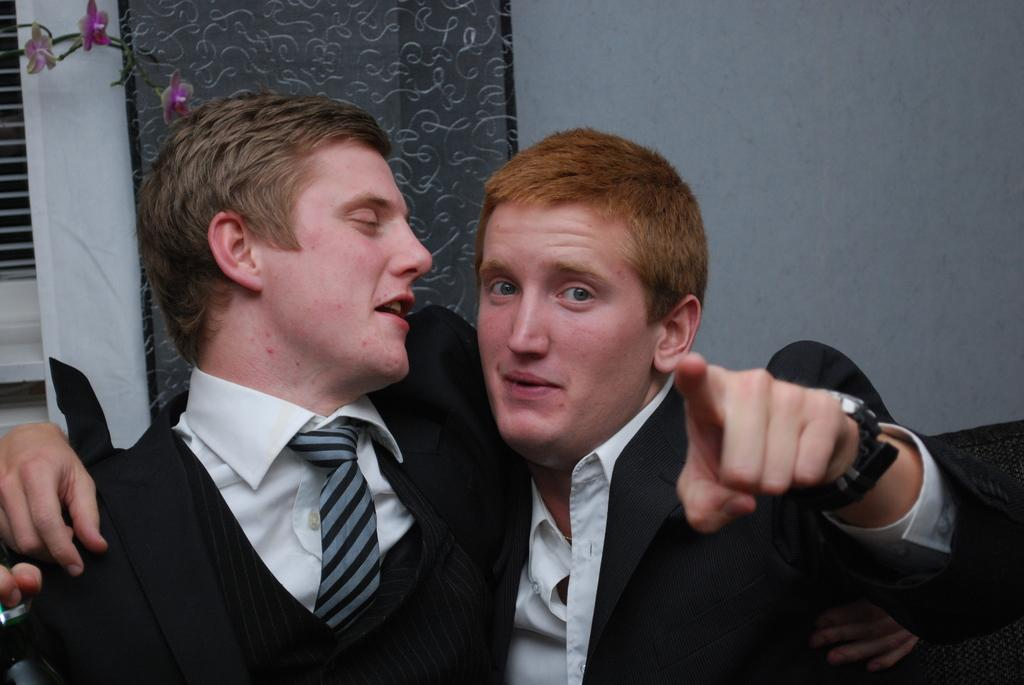How many people are in the image? There are two men in the image. Where are the men located? The men are in a room. What can be seen in the background of the image? There is a wall, a window, a curtain, and artificial flowers in the background of the image. What type of feather can be seen in the image? There is no feather present in the image. What discovery was made by the judge in the image? There is no judge or discovery present in the image. 